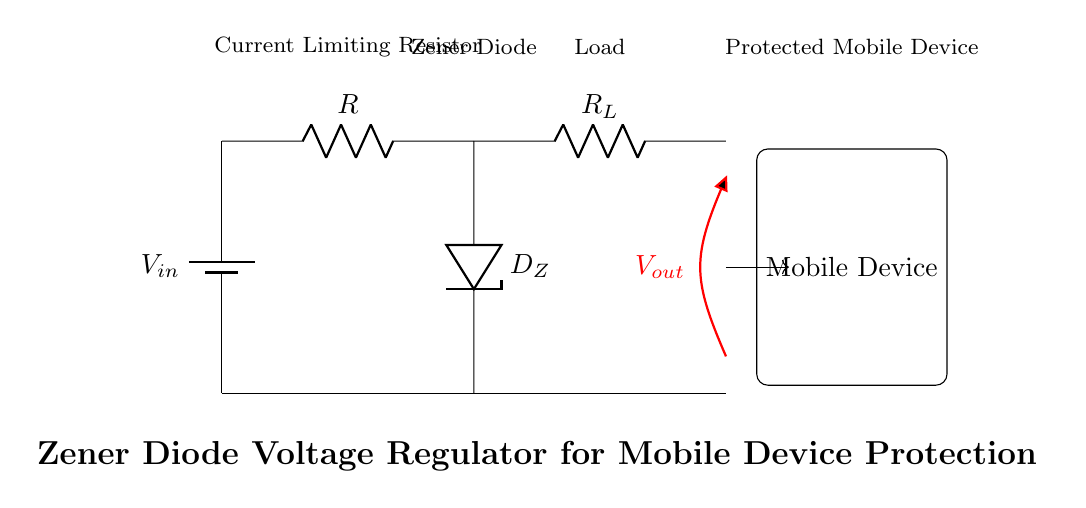What is the type of diode used in this circuit? The circuit uses a Zener diode, indicated by the label D_Z. The symbol shown in the diagram corresponds to a diode with reverse breakdown capability, which is used to maintain a constant output voltage.
Answer: Zener diode What is the role of the resistor labeled R? The resistor labeled R functions as a current limiting resistor to prevent excessive current from flowing through the Zener diode and the load, which could potentially damage the components. It ensures that the current stays within safe limits during operation.
Answer: Current limiting resistor What is the purpose of the Zener diode in this circuit? The purpose of the Zener diode is to regulate the output voltage across the load resistor (R_L) by allowing current to flow through it when the input voltage exceeds a certain threshold. This prevents over-voltage conditions that could harm the mobile device.
Answer: Voltage regulation What does the symbol labeled R_L represent? The symbol R_L represents the load resistor in the circuit, which simulates the resistance that the mobile device presents to the power supply. It is essential for controlling the current supplied to the mobile device.
Answer: Load resistor How does the circuit protect the mobile device from power surges? The circuit protects the mobile device by using the Zener diode to clamp the output voltage to a specified value, preventing voltage levels from exceeding the safe operating range for the mobile device. If a power surge occurs, the Zener diode conducts and directs excess voltage to ground, thereby safeguarding the connected device.
Answer: Voltage clamping What would happen if the Zener diode failed? If the Zener diode failed, it could result in the load experiencing higher than expected voltage, potentially damaging the mobile device connected to the circuit. Without the regulation mechanism, surges could pass directly through to the load resistor.
Answer: Device damage 